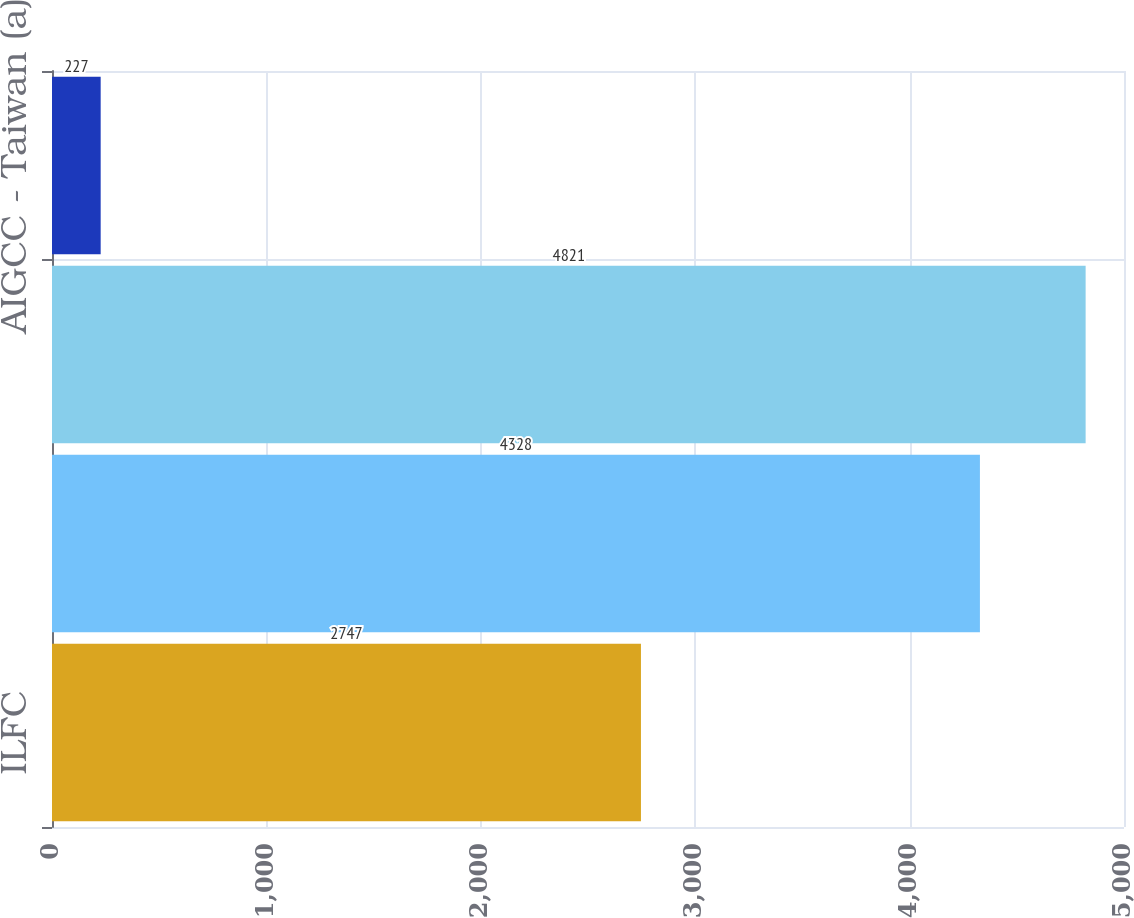Convert chart to OTSL. <chart><loc_0><loc_0><loc_500><loc_500><bar_chart><fcel>ILFC<fcel>AGF<fcel>AIG Funding<fcel>AIGCC - Taiwan (a)<nl><fcel>2747<fcel>4328<fcel>4821<fcel>227<nl></chart> 